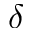<formula> <loc_0><loc_0><loc_500><loc_500>\delta</formula> 